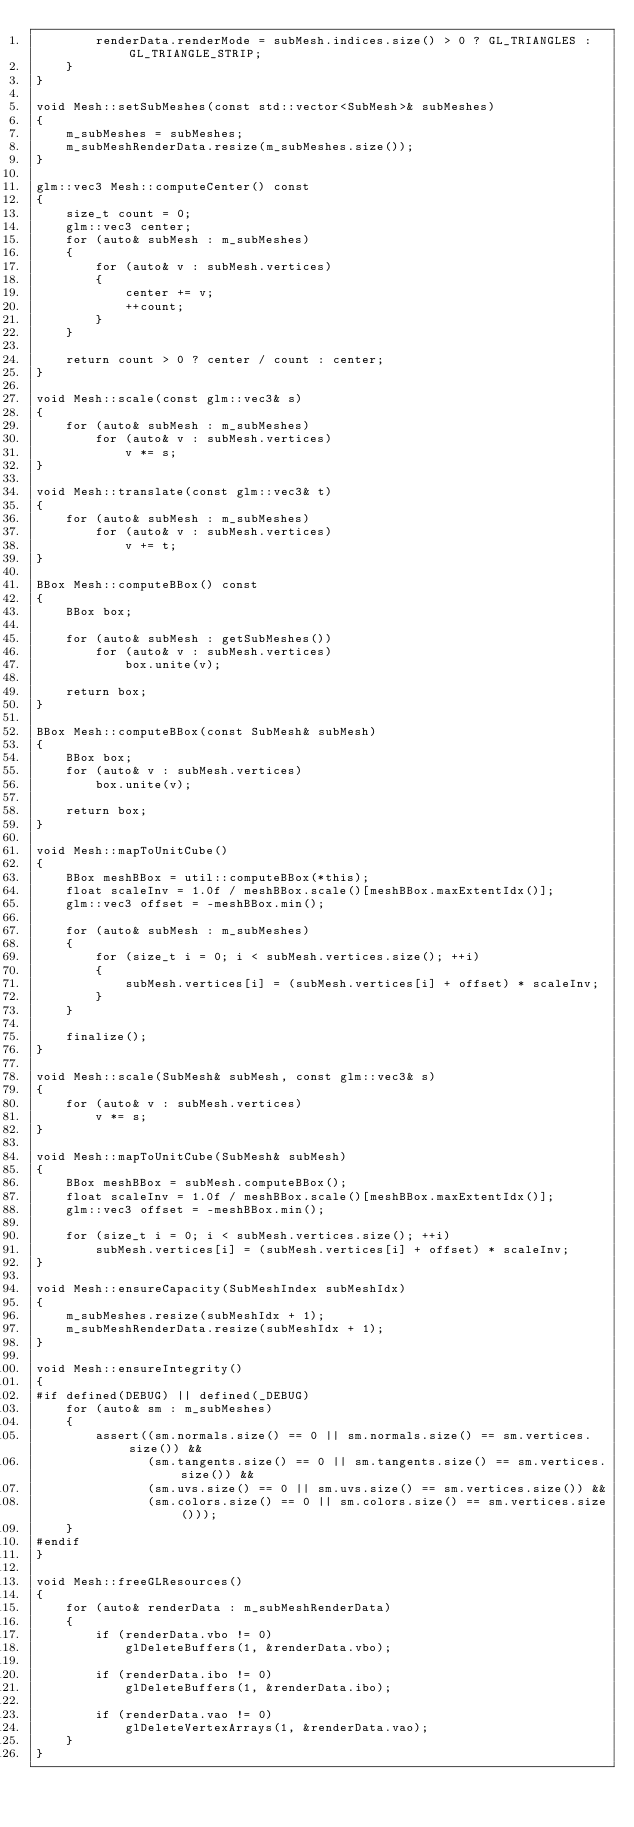<code> <loc_0><loc_0><loc_500><loc_500><_C++_>        renderData.renderMode = subMesh.indices.size() > 0 ? GL_TRIANGLES : GL_TRIANGLE_STRIP;
    }
}

void Mesh::setSubMeshes(const std::vector<SubMesh>& subMeshes)
{
    m_subMeshes = subMeshes;
    m_subMeshRenderData.resize(m_subMeshes.size());
}

glm::vec3 Mesh::computeCenter() const
{
    size_t count = 0;
    glm::vec3 center;
    for (auto& subMesh : m_subMeshes)
    {
        for (auto& v : subMesh.vertices)
        {
            center += v;
            ++count;
        }
    }

    return count > 0 ? center / count : center;
}

void Mesh::scale(const glm::vec3& s)
{
    for (auto& subMesh : m_subMeshes)
        for (auto& v : subMesh.vertices)
            v *= s;
}

void Mesh::translate(const glm::vec3& t)
{
    for (auto& subMesh : m_subMeshes)
        for (auto& v : subMesh.vertices)
            v += t;
}

BBox Mesh::computeBBox() const
{
    BBox box;

    for (auto& subMesh : getSubMeshes())
        for (auto& v : subMesh.vertices)
            box.unite(v);

    return box;
}

BBox Mesh::computeBBox(const SubMesh& subMesh)
{
	BBox box;
	for (auto& v : subMesh.vertices)
		box.unite(v);

	return box;
}

void Mesh::mapToUnitCube()
{
    BBox meshBBox = util::computeBBox(*this);
    float scaleInv = 1.0f / meshBBox.scale()[meshBBox.maxExtentIdx()];
    glm::vec3 offset = -meshBBox.min();

    for (auto& subMesh : m_subMeshes)
    {
        for (size_t i = 0; i < subMesh.vertices.size(); ++i)
        {
            subMesh.vertices[i] = (subMesh.vertices[i] + offset) * scaleInv;
        }
    }

    finalize();
}

void Mesh::scale(SubMesh& subMesh, const glm::vec3& s)
{
	for (auto& v : subMesh.vertices)
		v *= s;
}

void Mesh::mapToUnitCube(SubMesh& subMesh)
{
	BBox meshBBox = subMesh.computeBBox();
	float scaleInv = 1.0f / meshBBox.scale()[meshBBox.maxExtentIdx()];
	glm::vec3 offset = -meshBBox.min();

	for (size_t i = 0; i < subMesh.vertices.size(); ++i)
		subMesh.vertices[i] = (subMesh.vertices[i] + offset) * scaleInv;
}

void Mesh::ensureCapacity(SubMeshIndex subMeshIdx)
{
    m_subMeshes.resize(subMeshIdx + 1);
    m_subMeshRenderData.resize(subMeshIdx + 1);
}

void Mesh::ensureIntegrity()
{
#if defined(DEBUG) || defined(_DEBUG)
    for (auto& sm : m_subMeshes)
    {
        assert((sm.normals.size() == 0 || sm.normals.size() == sm.vertices.size()) &&
               (sm.tangents.size() == 0 || sm.tangents.size() == sm.vertices.size()) &&
               (sm.uvs.size() == 0 || sm.uvs.size() == sm.vertices.size()) &&
               (sm.colors.size() == 0 || sm.colors.size() == sm.vertices.size()));
    }
#endif
}

void Mesh::freeGLResources()
{
    for (auto& renderData : m_subMeshRenderData)
    {
        if (renderData.vbo != 0)
            glDeleteBuffers(1, &renderData.vbo);

        if (renderData.ibo != 0)
            glDeleteBuffers(1, &renderData.ibo);

        if (renderData.vao != 0)
            glDeleteVertexArrays(1, &renderData.vao);
    }
}
</code> 